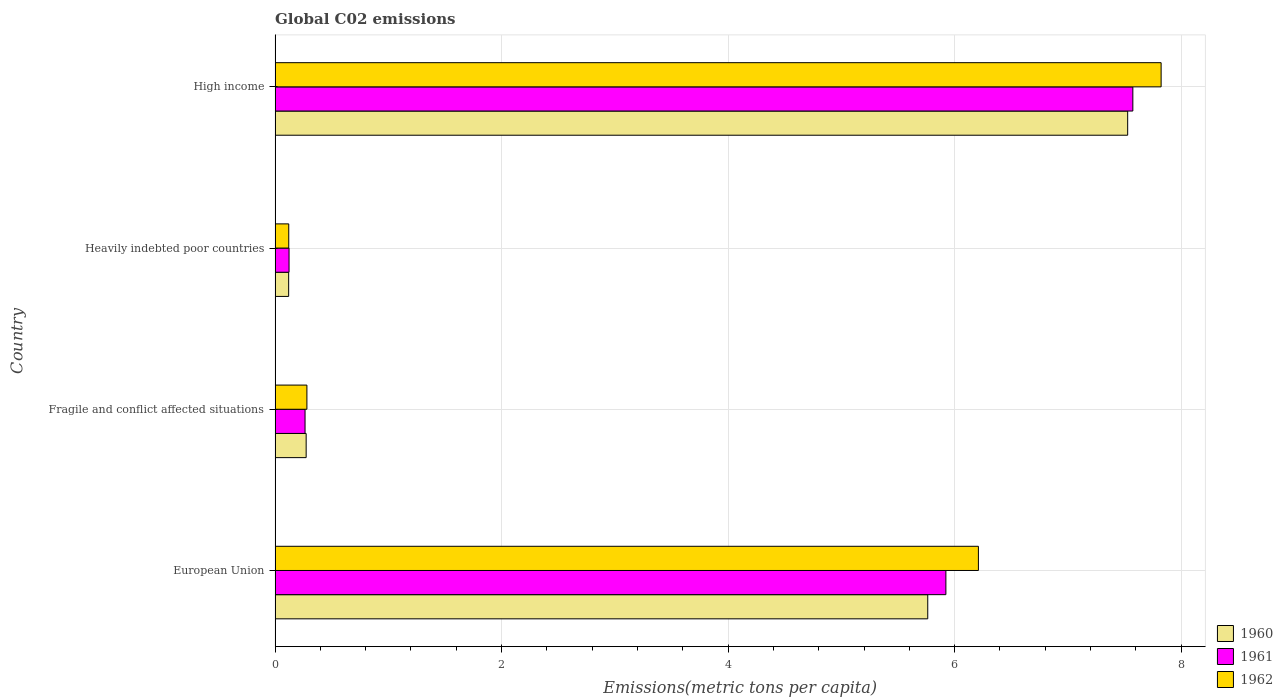How many groups of bars are there?
Your response must be concise. 4. Are the number of bars per tick equal to the number of legend labels?
Keep it short and to the point. Yes. Are the number of bars on each tick of the Y-axis equal?
Your answer should be very brief. Yes. How many bars are there on the 2nd tick from the bottom?
Your answer should be very brief. 3. What is the label of the 1st group of bars from the top?
Provide a succinct answer. High income. In how many cases, is the number of bars for a given country not equal to the number of legend labels?
Offer a very short reply. 0. What is the amount of CO2 emitted in in 1961 in Heavily indebted poor countries?
Provide a succinct answer. 0.12. Across all countries, what is the maximum amount of CO2 emitted in in 1961?
Your answer should be compact. 7.57. Across all countries, what is the minimum amount of CO2 emitted in in 1962?
Provide a short and direct response. 0.12. In which country was the amount of CO2 emitted in in 1961 minimum?
Provide a succinct answer. Heavily indebted poor countries. What is the total amount of CO2 emitted in in 1962 in the graph?
Offer a terse response. 14.44. What is the difference between the amount of CO2 emitted in in 1961 in European Union and that in Fragile and conflict affected situations?
Offer a terse response. 5.66. What is the difference between the amount of CO2 emitted in in 1960 in European Union and the amount of CO2 emitted in in 1962 in Fragile and conflict affected situations?
Provide a short and direct response. 5.48. What is the average amount of CO2 emitted in in 1962 per country?
Keep it short and to the point. 3.61. What is the difference between the amount of CO2 emitted in in 1962 and amount of CO2 emitted in in 1961 in High income?
Give a very brief answer. 0.25. In how many countries, is the amount of CO2 emitted in in 1961 greater than 7.6 metric tons per capita?
Make the answer very short. 0. What is the ratio of the amount of CO2 emitted in in 1960 in European Union to that in Heavily indebted poor countries?
Offer a terse response. 48.07. Is the amount of CO2 emitted in in 1962 in European Union less than that in High income?
Provide a short and direct response. Yes. Is the difference between the amount of CO2 emitted in in 1962 in European Union and High income greater than the difference between the amount of CO2 emitted in in 1961 in European Union and High income?
Ensure brevity in your answer.  Yes. What is the difference between the highest and the second highest amount of CO2 emitted in in 1960?
Your response must be concise. 1.77. What is the difference between the highest and the lowest amount of CO2 emitted in in 1962?
Your response must be concise. 7.7. What does the 1st bar from the top in Heavily indebted poor countries represents?
Provide a short and direct response. 1962. What does the 1st bar from the bottom in Heavily indebted poor countries represents?
Your response must be concise. 1960. How many bars are there?
Your answer should be very brief. 12. Are all the bars in the graph horizontal?
Offer a terse response. Yes. How many countries are there in the graph?
Offer a very short reply. 4. Does the graph contain grids?
Make the answer very short. Yes. Where does the legend appear in the graph?
Your response must be concise. Bottom right. How many legend labels are there?
Make the answer very short. 3. How are the legend labels stacked?
Provide a succinct answer. Vertical. What is the title of the graph?
Give a very brief answer. Global C02 emissions. Does "1998" appear as one of the legend labels in the graph?
Your answer should be compact. No. What is the label or title of the X-axis?
Your answer should be very brief. Emissions(metric tons per capita). What is the label or title of the Y-axis?
Offer a terse response. Country. What is the Emissions(metric tons per capita) in 1960 in European Union?
Make the answer very short. 5.76. What is the Emissions(metric tons per capita) in 1961 in European Union?
Provide a short and direct response. 5.92. What is the Emissions(metric tons per capita) of 1962 in European Union?
Give a very brief answer. 6.21. What is the Emissions(metric tons per capita) in 1960 in Fragile and conflict affected situations?
Keep it short and to the point. 0.27. What is the Emissions(metric tons per capita) in 1961 in Fragile and conflict affected situations?
Offer a very short reply. 0.26. What is the Emissions(metric tons per capita) of 1962 in Fragile and conflict affected situations?
Offer a very short reply. 0.28. What is the Emissions(metric tons per capita) of 1960 in Heavily indebted poor countries?
Offer a very short reply. 0.12. What is the Emissions(metric tons per capita) in 1961 in Heavily indebted poor countries?
Provide a short and direct response. 0.12. What is the Emissions(metric tons per capita) in 1962 in Heavily indebted poor countries?
Ensure brevity in your answer.  0.12. What is the Emissions(metric tons per capita) of 1960 in High income?
Give a very brief answer. 7.53. What is the Emissions(metric tons per capita) in 1961 in High income?
Make the answer very short. 7.57. What is the Emissions(metric tons per capita) of 1962 in High income?
Ensure brevity in your answer.  7.82. Across all countries, what is the maximum Emissions(metric tons per capita) in 1960?
Ensure brevity in your answer.  7.53. Across all countries, what is the maximum Emissions(metric tons per capita) in 1961?
Your answer should be very brief. 7.57. Across all countries, what is the maximum Emissions(metric tons per capita) in 1962?
Ensure brevity in your answer.  7.82. Across all countries, what is the minimum Emissions(metric tons per capita) of 1960?
Offer a terse response. 0.12. Across all countries, what is the minimum Emissions(metric tons per capita) in 1961?
Your response must be concise. 0.12. Across all countries, what is the minimum Emissions(metric tons per capita) in 1962?
Keep it short and to the point. 0.12. What is the total Emissions(metric tons per capita) of 1960 in the graph?
Keep it short and to the point. 13.69. What is the total Emissions(metric tons per capita) of 1961 in the graph?
Your answer should be very brief. 13.88. What is the total Emissions(metric tons per capita) of 1962 in the graph?
Offer a very short reply. 14.44. What is the difference between the Emissions(metric tons per capita) of 1960 in European Union and that in Fragile and conflict affected situations?
Provide a succinct answer. 5.49. What is the difference between the Emissions(metric tons per capita) in 1961 in European Union and that in Fragile and conflict affected situations?
Provide a short and direct response. 5.66. What is the difference between the Emissions(metric tons per capita) of 1962 in European Union and that in Fragile and conflict affected situations?
Your answer should be compact. 5.93. What is the difference between the Emissions(metric tons per capita) in 1960 in European Union and that in Heavily indebted poor countries?
Give a very brief answer. 5.64. What is the difference between the Emissions(metric tons per capita) of 1961 in European Union and that in Heavily indebted poor countries?
Your response must be concise. 5.8. What is the difference between the Emissions(metric tons per capita) in 1962 in European Union and that in Heavily indebted poor countries?
Your answer should be compact. 6.09. What is the difference between the Emissions(metric tons per capita) of 1960 in European Union and that in High income?
Your response must be concise. -1.77. What is the difference between the Emissions(metric tons per capita) in 1961 in European Union and that in High income?
Give a very brief answer. -1.65. What is the difference between the Emissions(metric tons per capita) in 1962 in European Union and that in High income?
Keep it short and to the point. -1.61. What is the difference between the Emissions(metric tons per capita) in 1960 in Fragile and conflict affected situations and that in Heavily indebted poor countries?
Your response must be concise. 0.15. What is the difference between the Emissions(metric tons per capita) in 1961 in Fragile and conflict affected situations and that in Heavily indebted poor countries?
Give a very brief answer. 0.14. What is the difference between the Emissions(metric tons per capita) of 1962 in Fragile and conflict affected situations and that in Heavily indebted poor countries?
Provide a short and direct response. 0.16. What is the difference between the Emissions(metric tons per capita) in 1960 in Fragile and conflict affected situations and that in High income?
Offer a very short reply. -7.25. What is the difference between the Emissions(metric tons per capita) in 1961 in Fragile and conflict affected situations and that in High income?
Ensure brevity in your answer.  -7.31. What is the difference between the Emissions(metric tons per capita) in 1962 in Fragile and conflict affected situations and that in High income?
Offer a terse response. -7.54. What is the difference between the Emissions(metric tons per capita) of 1960 in Heavily indebted poor countries and that in High income?
Offer a terse response. -7.41. What is the difference between the Emissions(metric tons per capita) of 1961 in Heavily indebted poor countries and that in High income?
Your answer should be very brief. -7.45. What is the difference between the Emissions(metric tons per capita) in 1962 in Heavily indebted poor countries and that in High income?
Your answer should be very brief. -7.7. What is the difference between the Emissions(metric tons per capita) in 1960 in European Union and the Emissions(metric tons per capita) in 1961 in Fragile and conflict affected situations?
Make the answer very short. 5.5. What is the difference between the Emissions(metric tons per capita) of 1960 in European Union and the Emissions(metric tons per capita) of 1962 in Fragile and conflict affected situations?
Your response must be concise. 5.48. What is the difference between the Emissions(metric tons per capita) in 1961 in European Union and the Emissions(metric tons per capita) in 1962 in Fragile and conflict affected situations?
Ensure brevity in your answer.  5.64. What is the difference between the Emissions(metric tons per capita) in 1960 in European Union and the Emissions(metric tons per capita) in 1961 in Heavily indebted poor countries?
Give a very brief answer. 5.64. What is the difference between the Emissions(metric tons per capita) of 1960 in European Union and the Emissions(metric tons per capita) of 1962 in Heavily indebted poor countries?
Provide a succinct answer. 5.64. What is the difference between the Emissions(metric tons per capita) in 1961 in European Union and the Emissions(metric tons per capita) in 1962 in Heavily indebted poor countries?
Your answer should be very brief. 5.8. What is the difference between the Emissions(metric tons per capita) in 1960 in European Union and the Emissions(metric tons per capita) in 1961 in High income?
Keep it short and to the point. -1.81. What is the difference between the Emissions(metric tons per capita) of 1960 in European Union and the Emissions(metric tons per capita) of 1962 in High income?
Your response must be concise. -2.06. What is the difference between the Emissions(metric tons per capita) of 1961 in European Union and the Emissions(metric tons per capita) of 1962 in High income?
Ensure brevity in your answer.  -1.9. What is the difference between the Emissions(metric tons per capita) of 1960 in Fragile and conflict affected situations and the Emissions(metric tons per capita) of 1961 in Heavily indebted poor countries?
Your answer should be very brief. 0.15. What is the difference between the Emissions(metric tons per capita) of 1960 in Fragile and conflict affected situations and the Emissions(metric tons per capita) of 1962 in Heavily indebted poor countries?
Ensure brevity in your answer.  0.15. What is the difference between the Emissions(metric tons per capita) of 1961 in Fragile and conflict affected situations and the Emissions(metric tons per capita) of 1962 in Heavily indebted poor countries?
Provide a succinct answer. 0.14. What is the difference between the Emissions(metric tons per capita) in 1960 in Fragile and conflict affected situations and the Emissions(metric tons per capita) in 1961 in High income?
Keep it short and to the point. -7.3. What is the difference between the Emissions(metric tons per capita) in 1960 in Fragile and conflict affected situations and the Emissions(metric tons per capita) in 1962 in High income?
Make the answer very short. -7.55. What is the difference between the Emissions(metric tons per capita) in 1961 in Fragile and conflict affected situations and the Emissions(metric tons per capita) in 1962 in High income?
Make the answer very short. -7.56. What is the difference between the Emissions(metric tons per capita) of 1960 in Heavily indebted poor countries and the Emissions(metric tons per capita) of 1961 in High income?
Keep it short and to the point. -7.45. What is the difference between the Emissions(metric tons per capita) of 1960 in Heavily indebted poor countries and the Emissions(metric tons per capita) of 1962 in High income?
Give a very brief answer. -7.7. What is the difference between the Emissions(metric tons per capita) in 1961 in Heavily indebted poor countries and the Emissions(metric tons per capita) in 1962 in High income?
Offer a very short reply. -7.7. What is the average Emissions(metric tons per capita) in 1960 per country?
Provide a succinct answer. 3.42. What is the average Emissions(metric tons per capita) in 1961 per country?
Provide a succinct answer. 3.47. What is the average Emissions(metric tons per capita) of 1962 per country?
Provide a short and direct response. 3.61. What is the difference between the Emissions(metric tons per capita) of 1960 and Emissions(metric tons per capita) of 1961 in European Union?
Provide a short and direct response. -0.16. What is the difference between the Emissions(metric tons per capita) in 1960 and Emissions(metric tons per capita) in 1962 in European Union?
Make the answer very short. -0.45. What is the difference between the Emissions(metric tons per capita) of 1961 and Emissions(metric tons per capita) of 1962 in European Union?
Ensure brevity in your answer.  -0.29. What is the difference between the Emissions(metric tons per capita) in 1960 and Emissions(metric tons per capita) in 1961 in Fragile and conflict affected situations?
Keep it short and to the point. 0.01. What is the difference between the Emissions(metric tons per capita) in 1960 and Emissions(metric tons per capita) in 1962 in Fragile and conflict affected situations?
Provide a succinct answer. -0.01. What is the difference between the Emissions(metric tons per capita) in 1961 and Emissions(metric tons per capita) in 1962 in Fragile and conflict affected situations?
Your answer should be compact. -0.02. What is the difference between the Emissions(metric tons per capita) of 1960 and Emissions(metric tons per capita) of 1961 in Heavily indebted poor countries?
Make the answer very short. -0. What is the difference between the Emissions(metric tons per capita) in 1960 and Emissions(metric tons per capita) in 1962 in Heavily indebted poor countries?
Your answer should be very brief. -0. What is the difference between the Emissions(metric tons per capita) in 1961 and Emissions(metric tons per capita) in 1962 in Heavily indebted poor countries?
Offer a very short reply. 0. What is the difference between the Emissions(metric tons per capita) in 1960 and Emissions(metric tons per capita) in 1961 in High income?
Keep it short and to the point. -0.05. What is the difference between the Emissions(metric tons per capita) in 1960 and Emissions(metric tons per capita) in 1962 in High income?
Offer a terse response. -0.3. What is the difference between the Emissions(metric tons per capita) in 1961 and Emissions(metric tons per capita) in 1962 in High income?
Give a very brief answer. -0.25. What is the ratio of the Emissions(metric tons per capita) in 1960 in European Union to that in Fragile and conflict affected situations?
Keep it short and to the point. 21. What is the ratio of the Emissions(metric tons per capita) in 1961 in European Union to that in Fragile and conflict affected situations?
Provide a succinct answer. 22.39. What is the ratio of the Emissions(metric tons per capita) in 1962 in European Union to that in Fragile and conflict affected situations?
Make the answer very short. 22.1. What is the ratio of the Emissions(metric tons per capita) in 1960 in European Union to that in Heavily indebted poor countries?
Give a very brief answer. 48.07. What is the ratio of the Emissions(metric tons per capita) of 1961 in European Union to that in Heavily indebted poor countries?
Offer a very short reply. 48.01. What is the ratio of the Emissions(metric tons per capita) of 1962 in European Union to that in Heavily indebted poor countries?
Your answer should be compact. 51.46. What is the ratio of the Emissions(metric tons per capita) of 1960 in European Union to that in High income?
Give a very brief answer. 0.77. What is the ratio of the Emissions(metric tons per capita) in 1961 in European Union to that in High income?
Ensure brevity in your answer.  0.78. What is the ratio of the Emissions(metric tons per capita) of 1962 in European Union to that in High income?
Provide a short and direct response. 0.79. What is the ratio of the Emissions(metric tons per capita) in 1960 in Fragile and conflict affected situations to that in Heavily indebted poor countries?
Your response must be concise. 2.29. What is the ratio of the Emissions(metric tons per capita) in 1961 in Fragile and conflict affected situations to that in Heavily indebted poor countries?
Provide a short and direct response. 2.14. What is the ratio of the Emissions(metric tons per capita) of 1962 in Fragile and conflict affected situations to that in Heavily indebted poor countries?
Offer a terse response. 2.33. What is the ratio of the Emissions(metric tons per capita) of 1960 in Fragile and conflict affected situations to that in High income?
Provide a short and direct response. 0.04. What is the ratio of the Emissions(metric tons per capita) of 1961 in Fragile and conflict affected situations to that in High income?
Keep it short and to the point. 0.03. What is the ratio of the Emissions(metric tons per capita) of 1962 in Fragile and conflict affected situations to that in High income?
Your response must be concise. 0.04. What is the ratio of the Emissions(metric tons per capita) of 1960 in Heavily indebted poor countries to that in High income?
Ensure brevity in your answer.  0.02. What is the ratio of the Emissions(metric tons per capita) in 1961 in Heavily indebted poor countries to that in High income?
Give a very brief answer. 0.02. What is the ratio of the Emissions(metric tons per capita) of 1962 in Heavily indebted poor countries to that in High income?
Offer a terse response. 0.02. What is the difference between the highest and the second highest Emissions(metric tons per capita) in 1960?
Your answer should be very brief. 1.77. What is the difference between the highest and the second highest Emissions(metric tons per capita) in 1961?
Your answer should be very brief. 1.65. What is the difference between the highest and the second highest Emissions(metric tons per capita) in 1962?
Offer a very short reply. 1.61. What is the difference between the highest and the lowest Emissions(metric tons per capita) in 1960?
Ensure brevity in your answer.  7.41. What is the difference between the highest and the lowest Emissions(metric tons per capita) of 1961?
Keep it short and to the point. 7.45. What is the difference between the highest and the lowest Emissions(metric tons per capita) in 1962?
Ensure brevity in your answer.  7.7. 